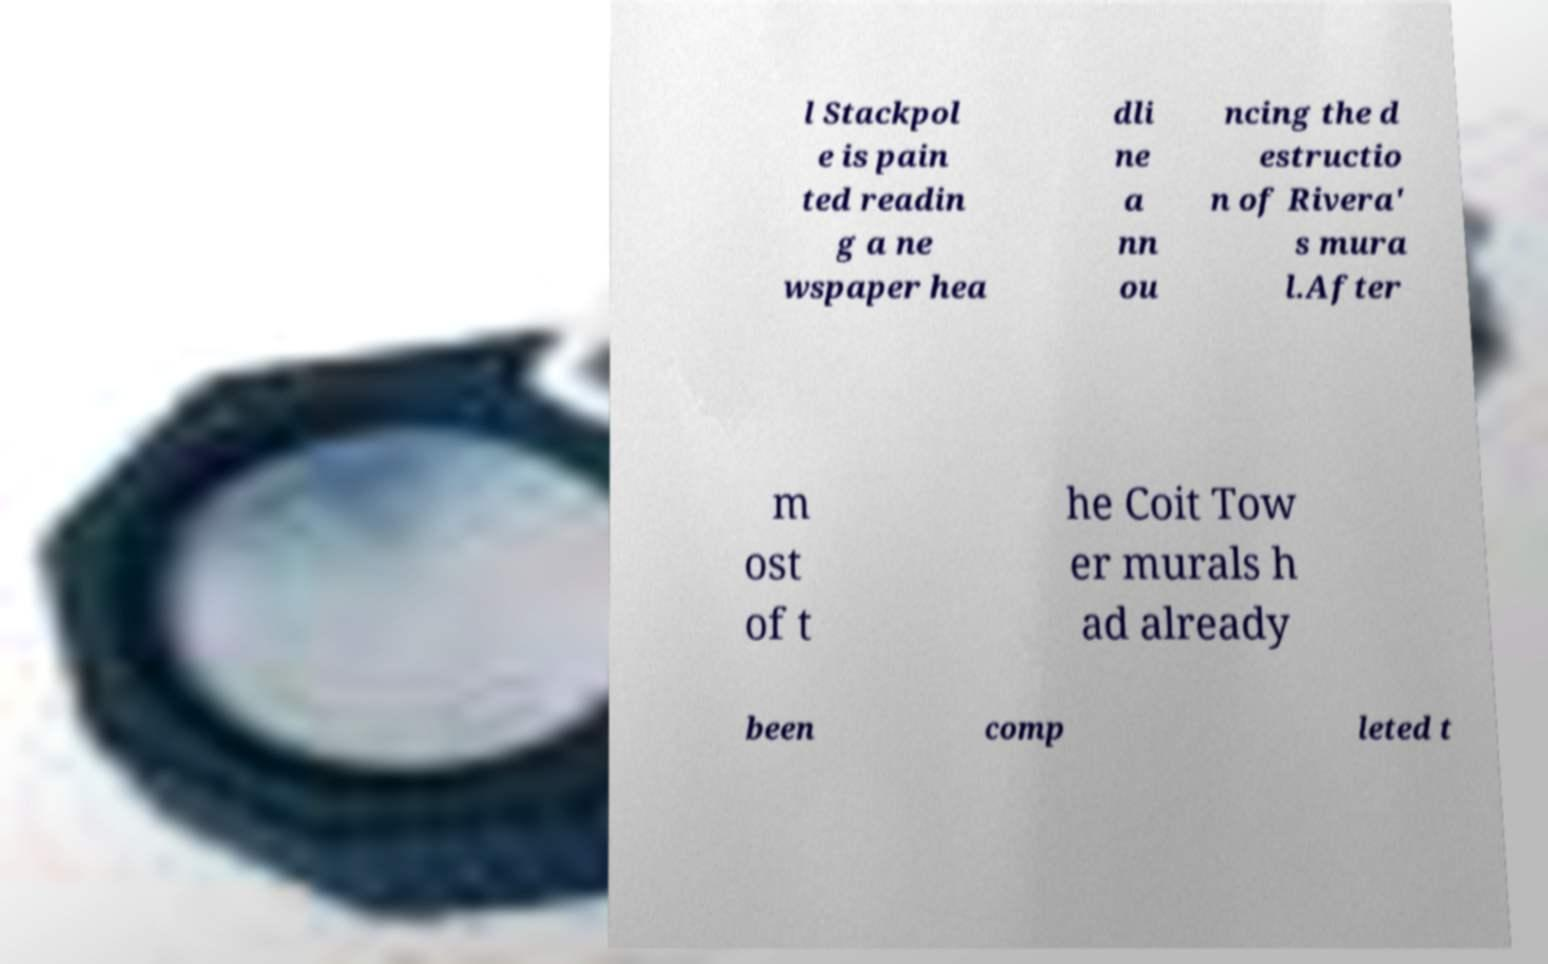Please identify and transcribe the text found in this image. l Stackpol e is pain ted readin g a ne wspaper hea dli ne a nn ou ncing the d estructio n of Rivera' s mura l.After m ost of t he Coit Tow er murals h ad already been comp leted t 